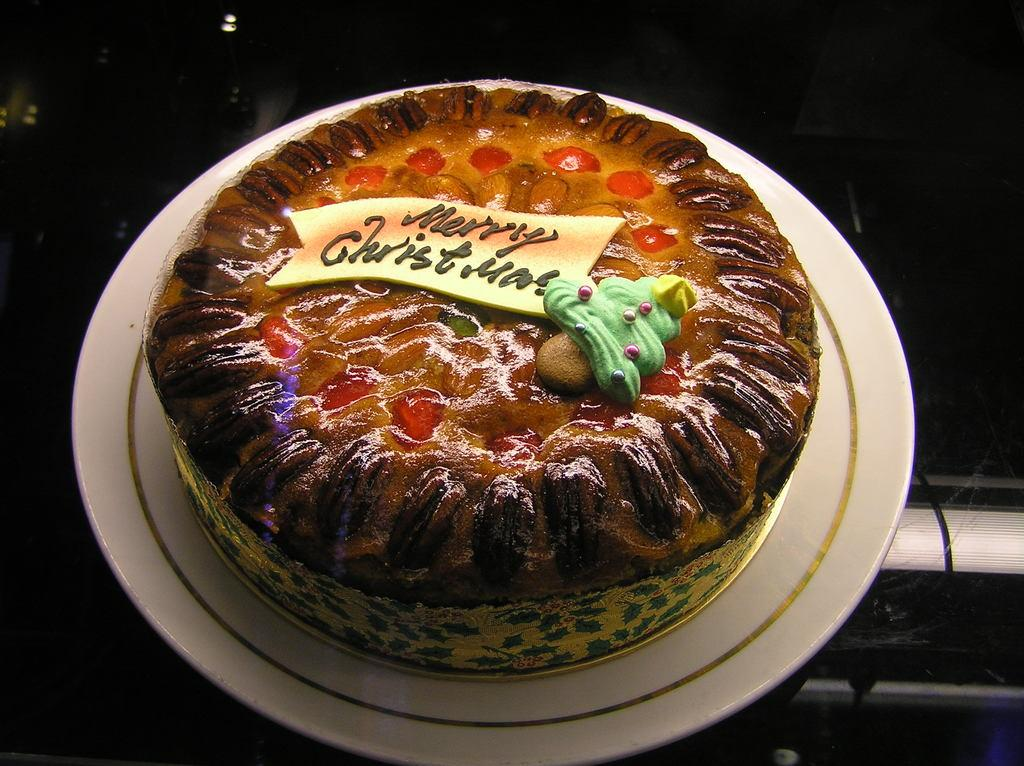What is on the plate that is visible in the image? There is a cake on the plate in the image. What is the color of the plate? The plate is white. Where is the plate located in the image? The plate is on a surface. What can be seen written on the cake? There is something written on the cake. What type of thread is used to decorate the cake in the image? There is no thread visible on the cake in the image. How does the spade help in the preparation of the cake in the image? There is no spade present in the image, and no indication of cake preparation. 